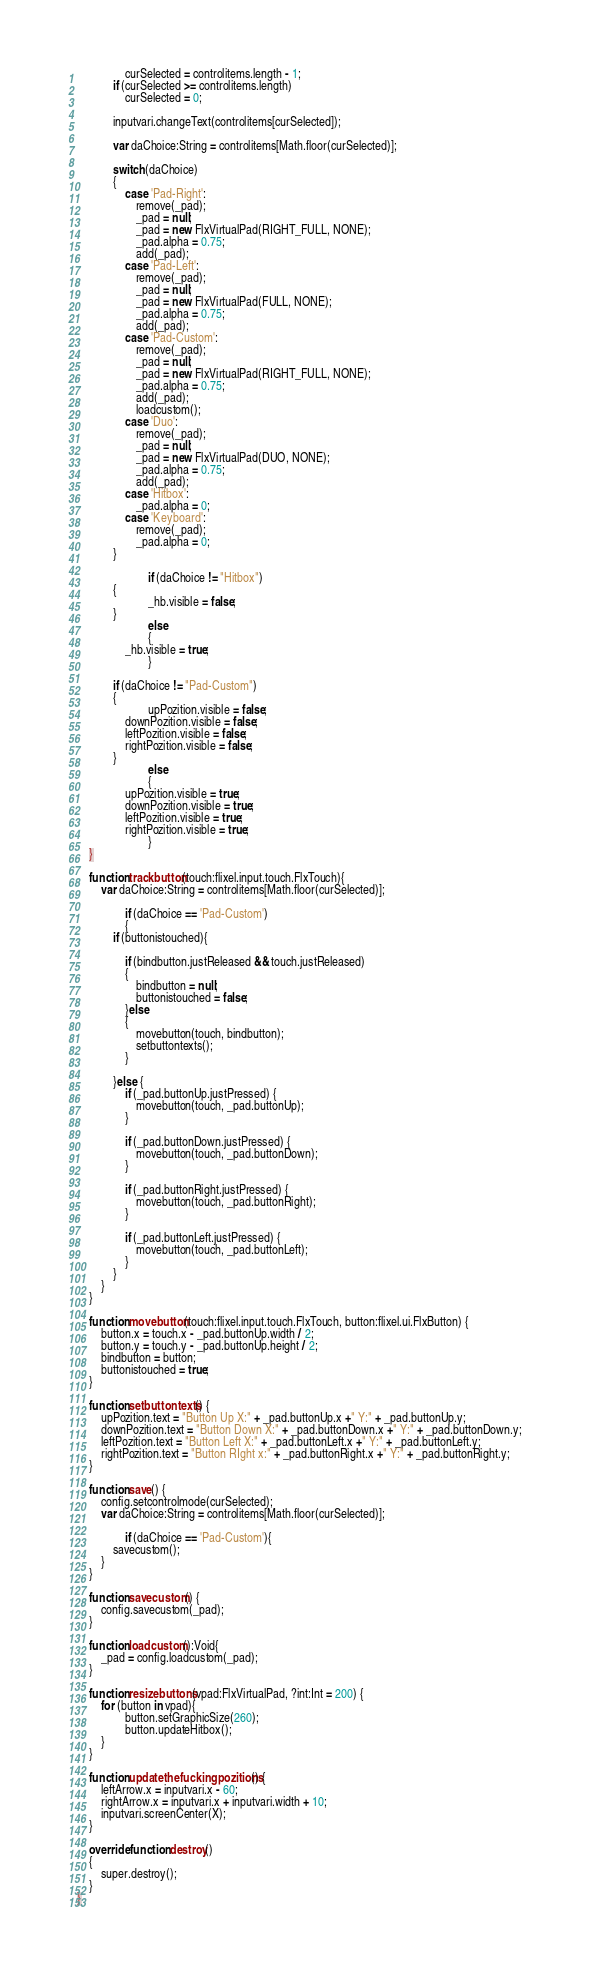<code> <loc_0><loc_0><loc_500><loc_500><_Haxe_>				curSelected = controlitems.length - 1;
			if (curSelected >= controlitems.length)
				curSelected = 0;
	
			inputvari.changeText(controlitems[curSelected]);

			var daChoice:String = controlitems[Math.floor(curSelected)];

			switch (daChoice)
			{
				case 'Pad-Right':
					remove(_pad);
					_pad = null;
					_pad = new FlxVirtualPad(RIGHT_FULL, NONE);
					_pad.alpha = 0.75;
					add(_pad);
				case 'Pad-Left':
					remove(_pad);
					_pad = null;
					_pad = new FlxVirtualPad(FULL, NONE);
					_pad.alpha = 0.75;
					add(_pad);
				case 'Pad-Custom':
					remove(_pad);
					_pad = null;
					_pad = new FlxVirtualPad(RIGHT_FULL, NONE);
					_pad.alpha = 0.75;
					add(_pad);
					loadcustom();
				case 'Duo':
					remove(_pad);
					_pad = null;
					_pad = new FlxVirtualPad(DUO, NONE);
					_pad.alpha = 0.75;
					add(_pad);
				case 'Hitbox':
					_pad.alpha = 0;                         
				case 'Keyboard':                     
					remove(_pad);
					_pad.alpha = 0;
			}

                        if (daChoice != "Hitbox")
			{
		                _hb.visible = false;
			}
                        else
                        {
				_hb.visible = true;
                        }

			if (daChoice != "Pad-Custom")
			{
		                upPozition.visible = false;
				downPozition.visible = false;
				leftPozition.visible = false;
				rightPozition.visible = false;
			}
                        else
                        {
				upPozition.visible = true;
				downPozition.visible = true;
				leftPozition.visible = true;
				rightPozition.visible = true;
                        }
	}

	function trackbutton(touch:flixel.input.touch.FlxTouch){
		var daChoice:String = controlitems[Math.floor(curSelected)];

                if (daChoice == 'Pad-Custom')
                {
			if (buttonistouched){
				
				if (bindbutton.justReleased && touch.justReleased)
				{
					bindbutton = null;
					buttonistouched = false;
				}else 
				{
					movebutton(touch, bindbutton);
					setbuttontexts();
				}

			}else {
				if (_pad.buttonUp.justPressed) {
					movebutton(touch, _pad.buttonUp);
				}
				
				if (_pad.buttonDown.justPressed) {
					movebutton(touch, _pad.buttonDown);
				}

				if (_pad.buttonRight.justPressed) {
					movebutton(touch, _pad.buttonRight);
				}

				if (_pad.buttonLeft.justPressed) {
					movebutton(touch, _pad.buttonLeft);
				}
			}
        }
	}

	function movebutton(touch:flixel.input.touch.FlxTouch, button:flixel.ui.FlxButton) {
		button.x = touch.x - _pad.buttonUp.width / 2;
		button.y = touch.y - _pad.buttonUp.height / 2;
		bindbutton = button;
		buttonistouched = true;
	}

	function setbuttontexts() {
		upPozition.text = "Button Up X:" + _pad.buttonUp.x +" Y:" + _pad.buttonUp.y;
		downPozition.text = "Button Down X:" + _pad.buttonDown.x +" Y:" + _pad.buttonDown.y;
		leftPozition.text = "Button Left X:" + _pad.buttonLeft.x +" Y:" + _pad.buttonLeft.y;
		rightPozition.text = "Button RIght x:" + _pad.buttonRight.x +" Y:" + _pad.buttonRight.y;
	}

	function save() {
		config.setcontrolmode(curSelected);
		var daChoice:String = controlitems[Math.floor(curSelected)];

    	        if (daChoice == 'Pad-Custom'){
			savecustom();
		}
	}

	function savecustom() {
		config.savecustom(_pad);
	}

	function loadcustom():Void{
		_pad = config.loadcustom(_pad);	
	}

	function resizebuttons(vpad:FlxVirtualPad, ?int:Int = 200) {
		for (button in vpad){
				button.setGraphicSize(260);
				button.updateHitbox();
		}
	}

	function updatethefuckingpozitions() {
		leftArrow.x = inputvari.x - 60;
		rightArrow.x = inputvari.x + inputvari.width + 10;
		inputvari.screenCenter(X);
	}

	override function destroy()
	{
		super.destroy();
	}
}
</code> 